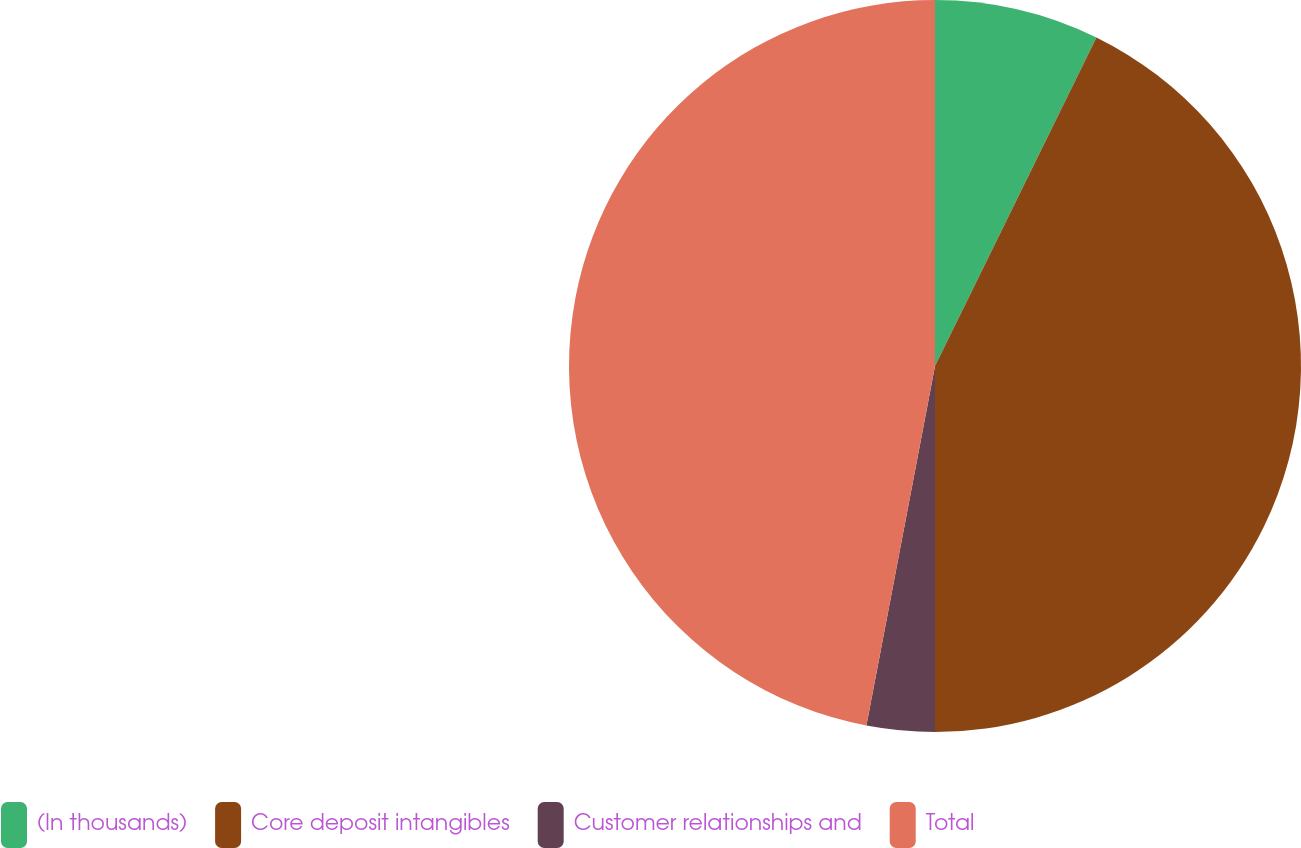Convert chart to OTSL. <chart><loc_0><loc_0><loc_500><loc_500><pie_chart><fcel>(In thousands)<fcel>Core deposit intangibles<fcel>Customer relationships and<fcel>Total<nl><fcel>7.27%<fcel>42.73%<fcel>3.0%<fcel>47.0%<nl></chart> 